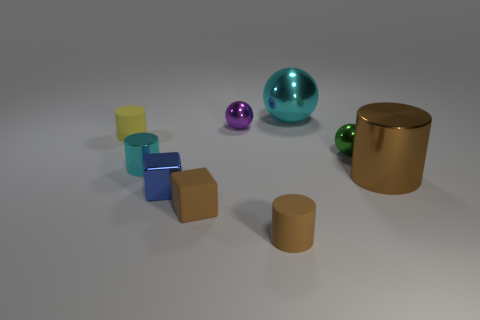Subtract all gray cylinders. Subtract all green balls. How many cylinders are left? 4 Add 1 tiny red blocks. How many objects exist? 10 Subtract all cylinders. How many objects are left? 5 Subtract 0 red cubes. How many objects are left? 9 Subtract all large objects. Subtract all big cyan things. How many objects are left? 6 Add 1 tiny yellow matte cylinders. How many tiny yellow matte cylinders are left? 2 Add 5 tiny blue metallic blocks. How many tiny blue metallic blocks exist? 6 